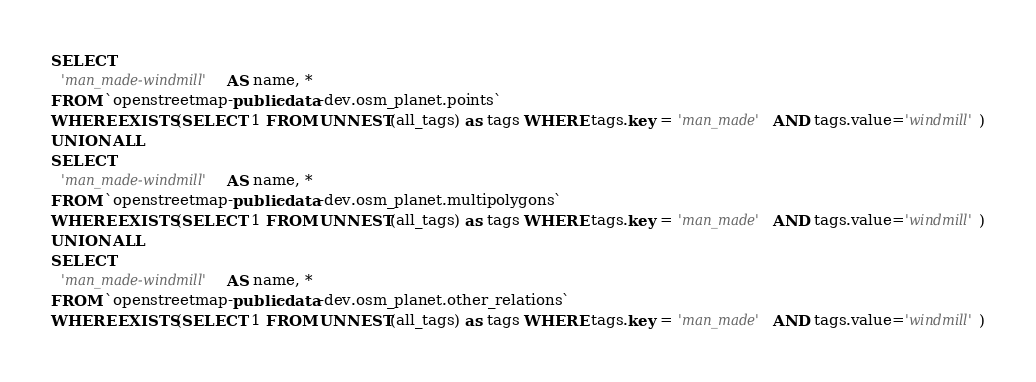<code> <loc_0><loc_0><loc_500><loc_500><_SQL_>SELECT
  'man_made-windmill' AS name, *
FROM `openstreetmap-public-data-dev.osm_planet.points`
WHERE EXISTS(SELECT 1 FROM UNNEST(all_tags) as tags WHERE tags.key = 'man_made' AND tags.value='windmill')
UNION ALL
SELECT
  'man_made-windmill' AS name, *
FROM `openstreetmap-public-data-dev.osm_planet.multipolygons`
WHERE EXISTS(SELECT 1 FROM UNNEST(all_tags) as tags WHERE tags.key = 'man_made' AND tags.value='windmill')
UNION ALL
SELECT
  'man_made-windmill' AS name, *
FROM `openstreetmap-public-data-dev.osm_planet.other_relations`
WHERE EXISTS(SELECT 1 FROM UNNEST(all_tags) as tags WHERE tags.key = 'man_made' AND tags.value='windmill')

</code> 